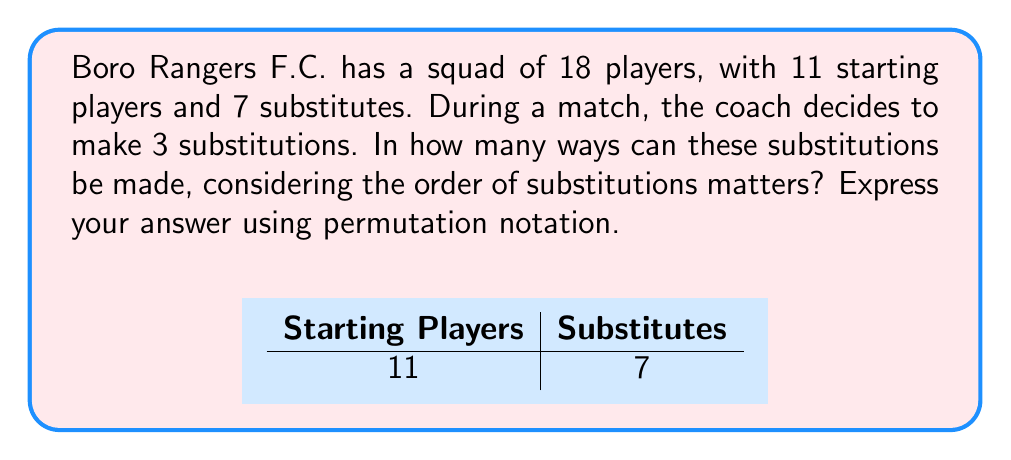Solve this math problem. Let's approach this step-by-step:

1) We are selecting 3 players from the 7 substitutes to come onto the field. The order matters because the sequence of substitutions is important.

2) This scenario is a permutation problem. We are arranging 3 players out of 7, where the order matters.

3) The formula for permutations is:

   $$P(n,r) = \frac{n!}{(n-r)!}$$

   Where $n$ is the total number of items to choose from, and $r$ is the number of items being chosen.

4) In this case, $n = 7$ (total substitutes) and $r = 3$ (number of substitutions).

5) Plugging these values into our formula:

   $$P(7,3) = \frac{7!}{(7-3)!} = \frac{7!}{4!}$$

6) Expanding this:
   
   $$\frac{7 \times 6 \times 5 \times 4!}{4!}$$

7) The $4!$ cancels out in the numerator and denominator:

   $$7 \times 6 \times 5 = 210$$

Therefore, there are 210 ways to make these substitutions.
Answer: $P(7,3) = 210$ 